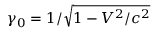Convert formula to latex. <formula><loc_0><loc_0><loc_500><loc_500>\gamma _ { 0 } = 1 / \sqrt { 1 - V ^ { 2 } / c ^ { 2 } }</formula> 